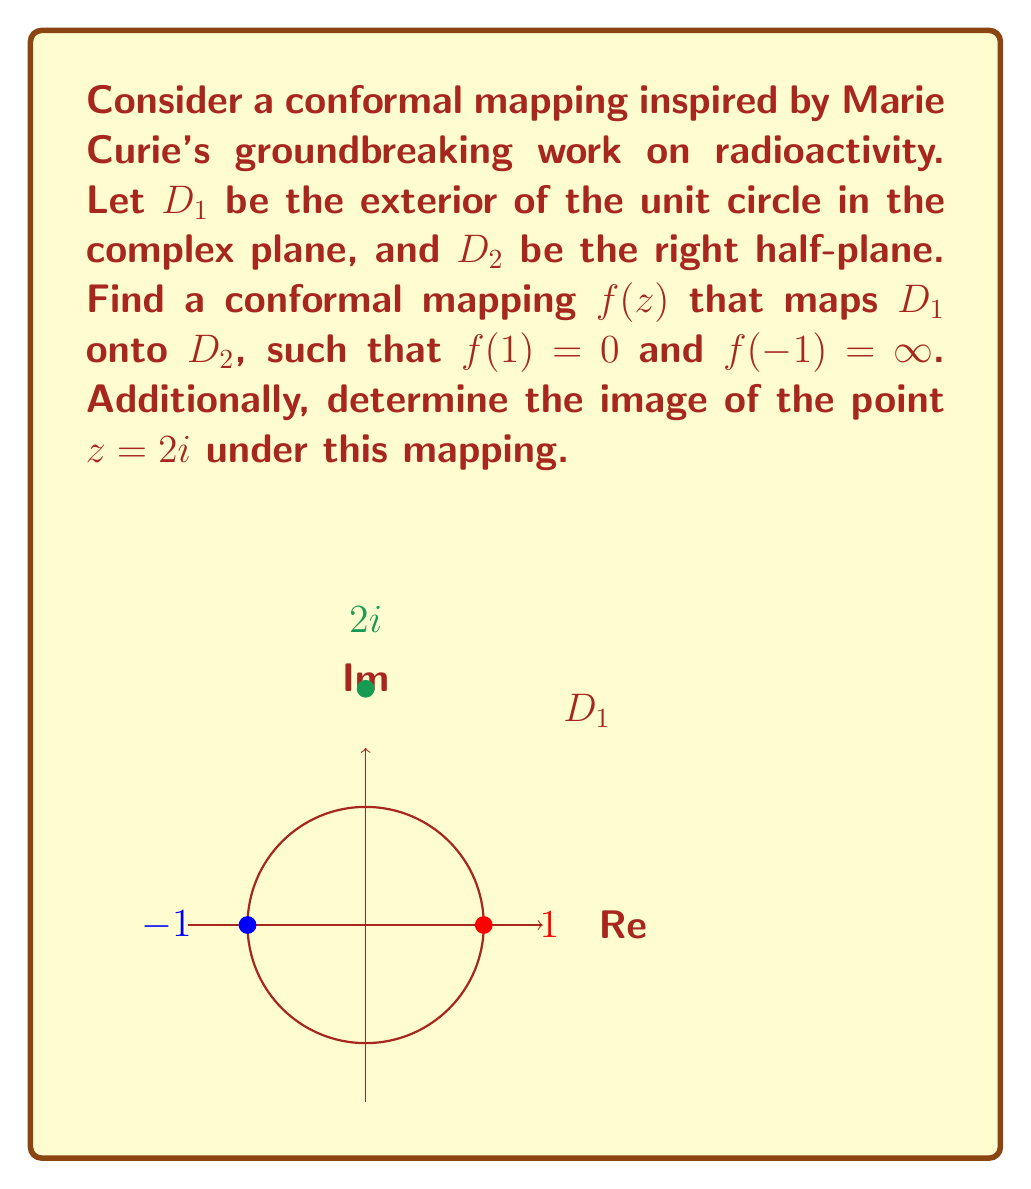Could you help me with this problem? To solve this problem, we'll follow these steps:

1) The Möbius transformation $w = \frac{z-1}{z+1}$ maps the exterior of the unit circle to the right half-plane. Let's verify this:

   - When $|z| = 1$, $z = e^{i\theta}$, and $w = \frac{e^{i\theta}-1}{e^{i\theta}+1} = i\tan(\frac{\theta}{2})$, which is purely imaginary.
   - When $|z| > 1$, the real part of $w$ is positive.

2) This mapping satisfies $f(1) = 0$ and $f(-1) = \infty$, as required.

3) Therefore, our conformal mapping is:

   $$f(z) = \frac{z-1}{z+1}$$

4) To find the image of $z = 2i$ under this mapping:

   $$f(2i) = \frac{2i-1}{2i+1} = \frac{(2i-1)(2i-1)}{(2i+1)(2i-1)} = \frac{4i^2-2i+2i-1}{4i^2+2i-2i-1} = \frac{-5+0i}{-5+0i} = 1$$

Thus, the point $2i$ in $D_1$ is mapped to the point $1$ in $D_2$.
Answer: $f(z) = \frac{z-1}{z+1}$; $f(2i) = 1$ 